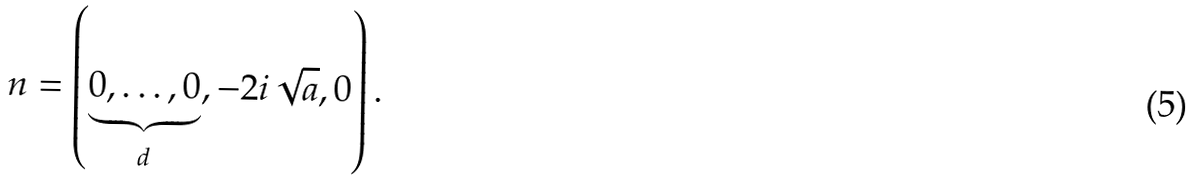Convert formula to latex. <formula><loc_0><loc_0><loc_500><loc_500>n = \left ( \underbrace { 0 , \dots , 0 } _ { d } , - 2 i \sqrt { a } , 0 \right ) .</formula> 